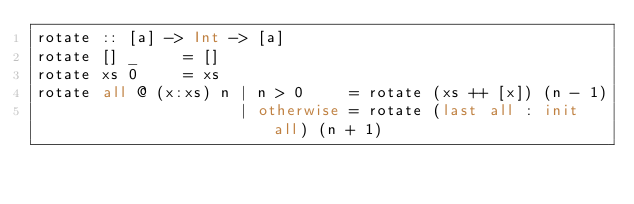Convert code to text. <code><loc_0><loc_0><loc_500><loc_500><_Haskell_>rotate :: [a] -> Int -> [a]
rotate [] _     = []
rotate xs 0     = xs
rotate all @ (x:xs) n | n > 0     = rotate (xs ++ [x]) (n - 1)
                      | otherwise = rotate (last all : init all) (n + 1)</code> 